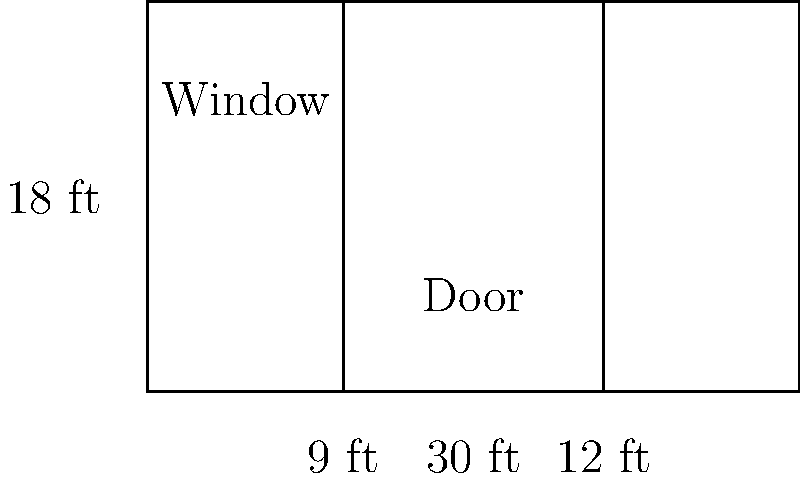You're planning to allow an artist to paint a mural on the front of your building. The building's front wall is rectangular, measuring 30 feet wide and 18 feet high. There's a door in the center that's 9 feet wide and 12 feet high, and a window on the left side that's 6 feet wide and 4 feet high. What is the total area, in square feet, available for the mural after subtracting the areas of the door and window? Let's solve this problem step by step:

1. Calculate the total area of the wall:
   Area = width × height
   $A_{wall} = 30 \text{ ft} \times 18 \text{ ft} = 540 \text{ sq ft}$

2. Calculate the area of the door:
   $A_{door} = 9 \text{ ft} \times 12 \text{ ft} = 108 \text{ sq ft}$

3. Calculate the area of the window:
   $A_{window} = 6 \text{ ft} \times 4 \text{ ft} = 24 \text{ sq ft}$

4. Calculate the total area occupied by the door and window:
   $A_{occupied} = A_{door} + A_{window} = 108 \text{ sq ft} + 24 \text{ sq ft} = 132 \text{ sq ft}$

5. Calculate the area available for the mural by subtracting the occupied area from the total wall area:
   $A_{mural} = A_{wall} - A_{occupied} = 540 \text{ sq ft} - 132 \text{ sq ft} = 408 \text{ sq ft}$

Therefore, the total area available for the mural is 408 square feet.
Answer: 408 sq ft 